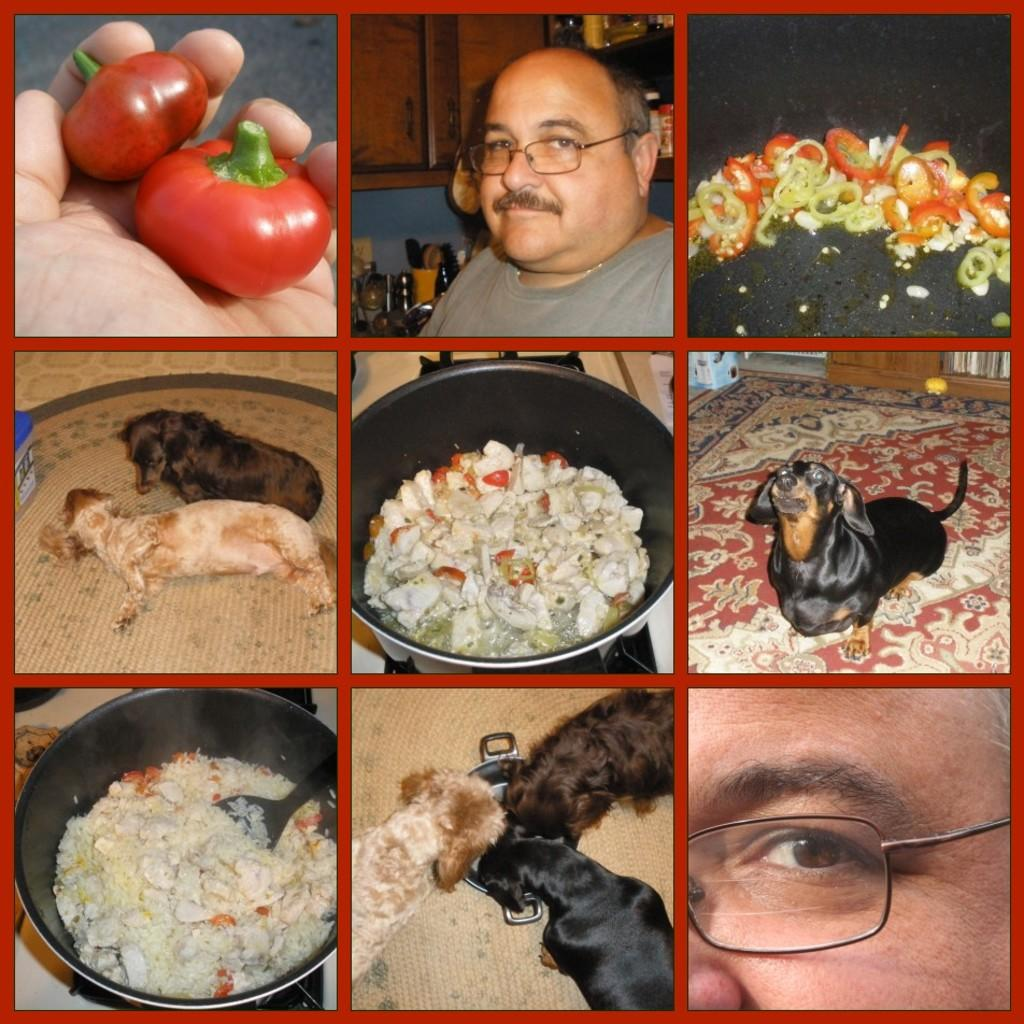What type of artwork is the image? The image is a collage. What animals are featured in the collage? There are dogs in the image. What object is present in the collage that might be used for serving food? There is a bowl in the image. What type of food can be seen in the collage? There is food in the image, including tomatoes. Can you identify a person in the collage? Yes, there is a person in the image. What type of wound can be seen on the person in the image? There is no wound visible on the person in the image. What type of yard is shown in the image? The image does not depict a yard; it is a collage featuring dogs, a bowl, food, and a person. 